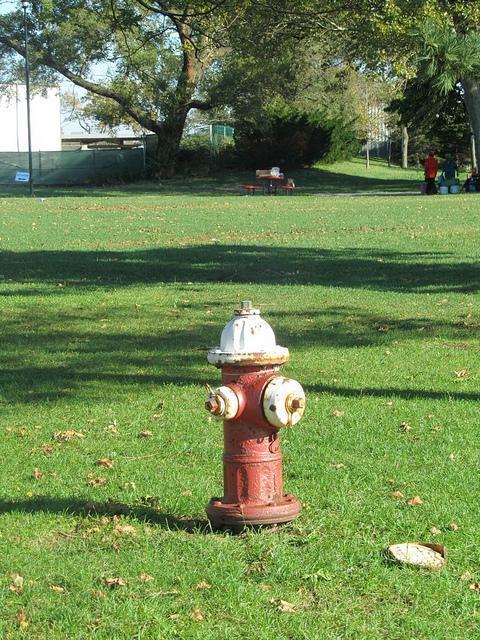Where is the fire hydrant located?
Indicate the correct response and explain using: 'Answer: answer
Rationale: rationale.'
Options: Park, village, city, farm. Answer: park.
Rationale: There is a lot of grass, but it is taken care of.  you can see people enjoying their day. 